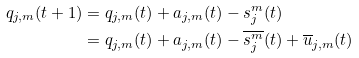<formula> <loc_0><loc_0><loc_500><loc_500>q _ { j , m } ( t + 1 ) & = q _ { j , m } ( t ) + a _ { j , m } ( t ) - s _ { j } ^ { m } ( t ) \\ & = q _ { j , m } ( t ) + a _ { j , m } ( t ) - \overline { s _ { j } ^ { m } } ( t ) + \overline { u } _ { j , m } ( t )</formula> 